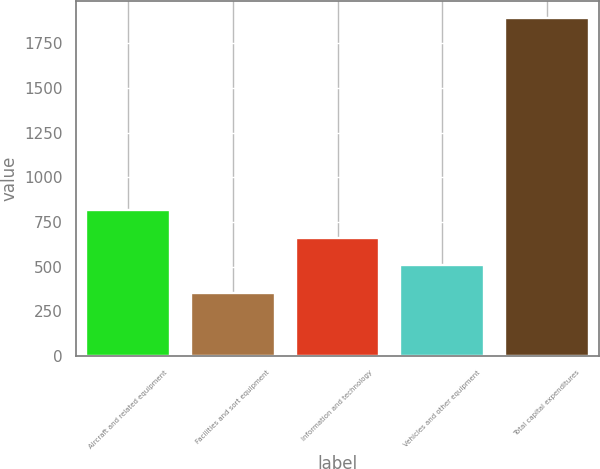<chart> <loc_0><loc_0><loc_500><loc_500><bar_chart><fcel>Aircraft and related equipment<fcel>Facilities and sort equipment<fcel>Information and technology<fcel>Vehicles and other equipment<fcel>Total capital expenditures<nl><fcel>815<fcel>353<fcel>661<fcel>507<fcel>1893<nl></chart> 